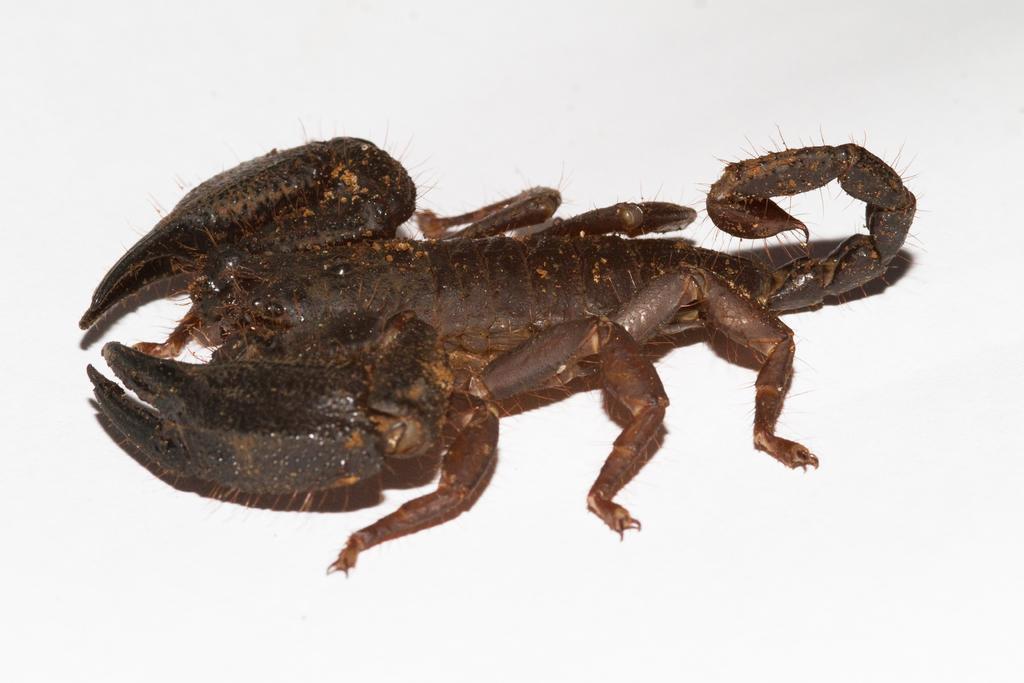Could you give a brief overview of what you see in this image? In this image in the center there is a scorpion, and there is white background. 